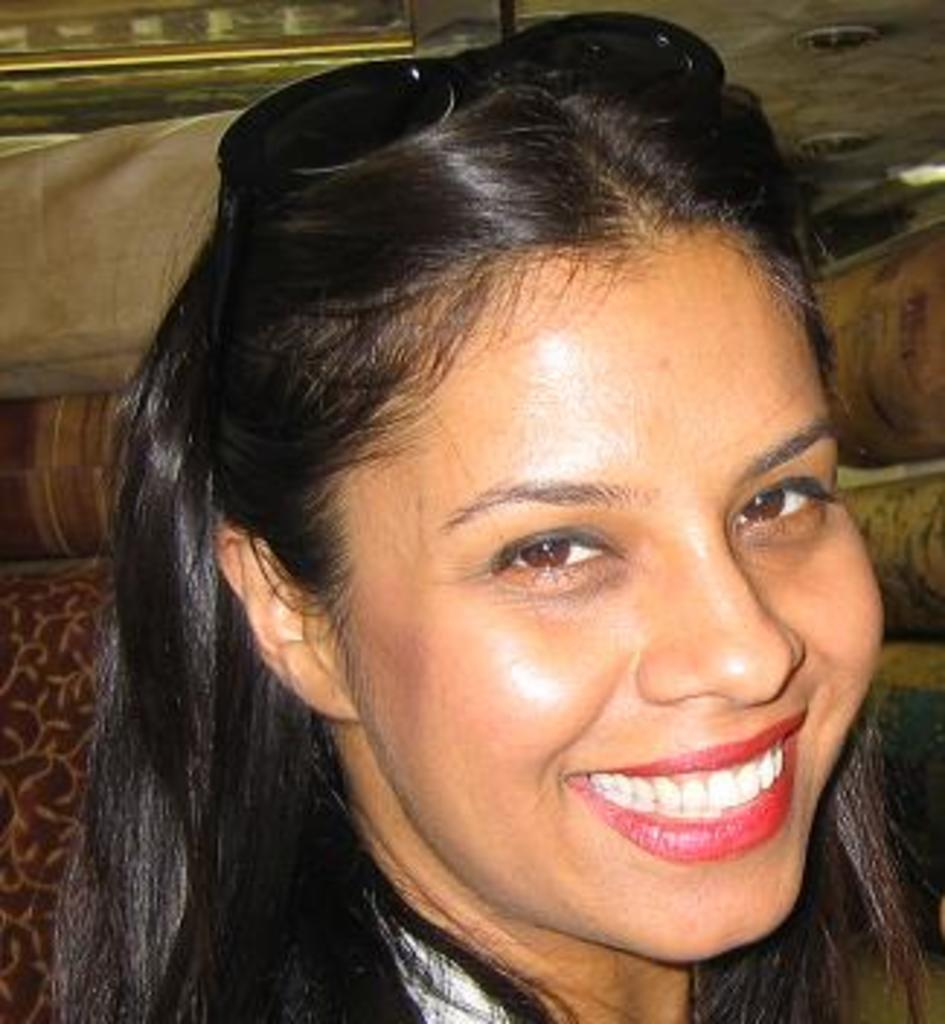Who is present in the image? There is a woman in the image. What is the woman's facial expression? The woman is smiling. Can you describe the background of the image? There are objects in the background of the image. What type of root can be seen growing from the woman's head in the image? There is no root growing from the woman's head in the image. 